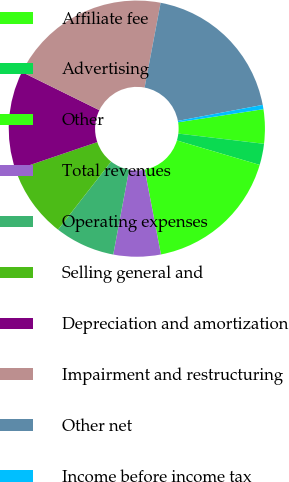<chart> <loc_0><loc_0><loc_500><loc_500><pie_chart><fcel>Affiliate fee<fcel>Advertising<fcel>Other<fcel>Total revenues<fcel>Operating expenses<fcel>Selling general and<fcel>Depreciation and amortization<fcel>Impairment and restructuring<fcel>Other net<fcel>Income before income tax<nl><fcel>4.32%<fcel>2.68%<fcel>17.42%<fcel>5.96%<fcel>7.6%<fcel>9.23%<fcel>12.51%<fcel>20.69%<fcel>19.06%<fcel>0.54%<nl></chart> 